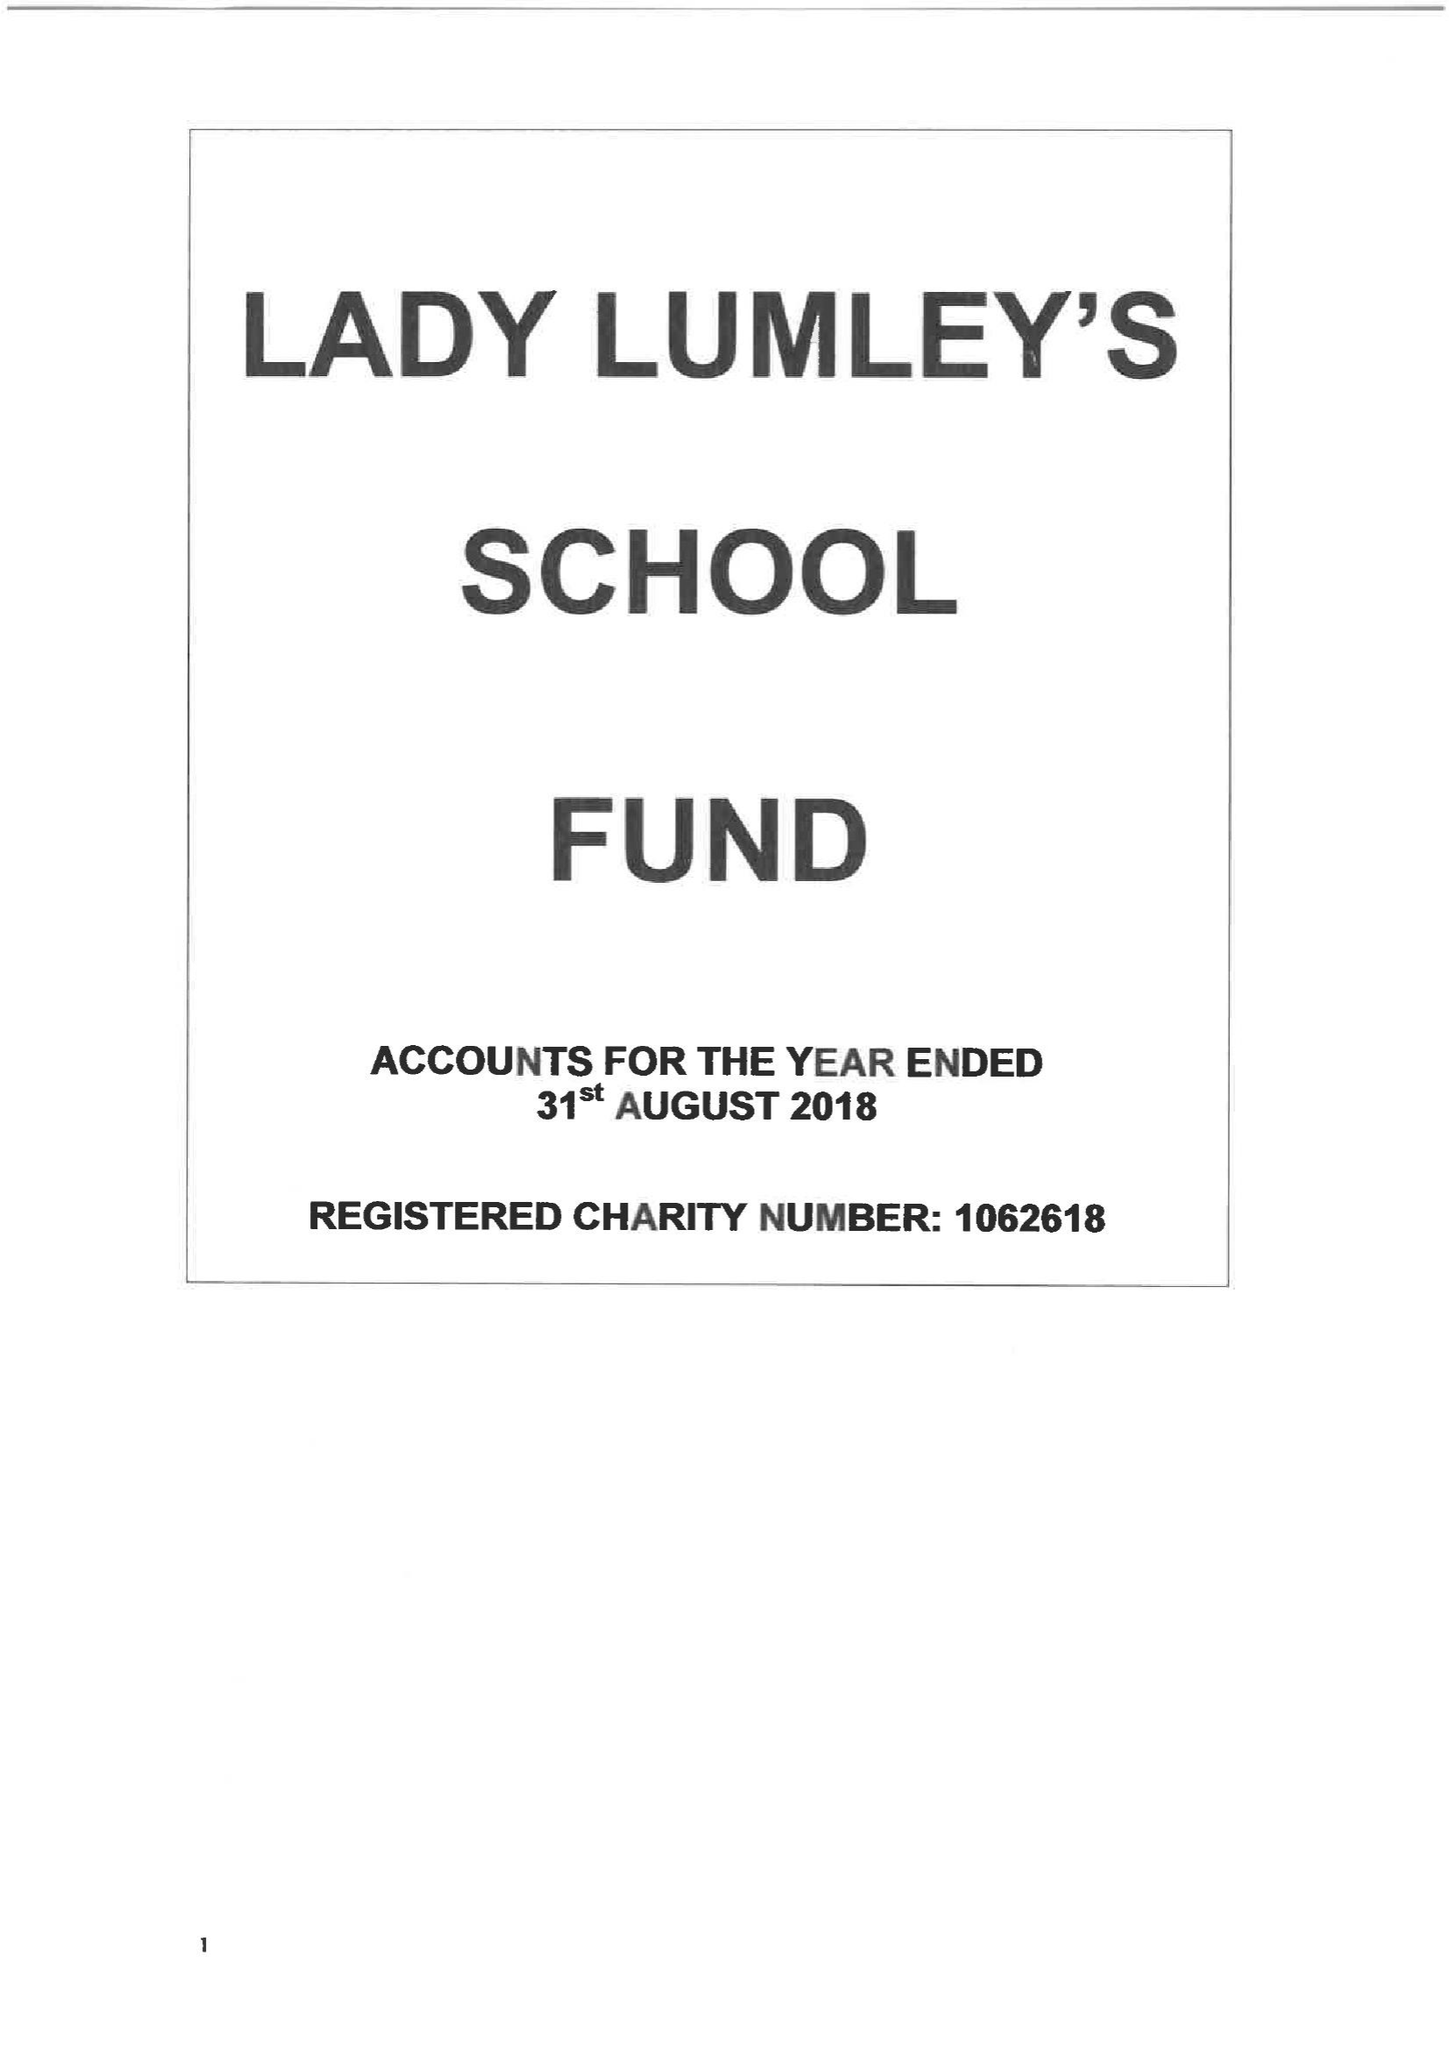What is the value for the spending_annually_in_british_pounds?
Answer the question using a single word or phrase. 42582.00 